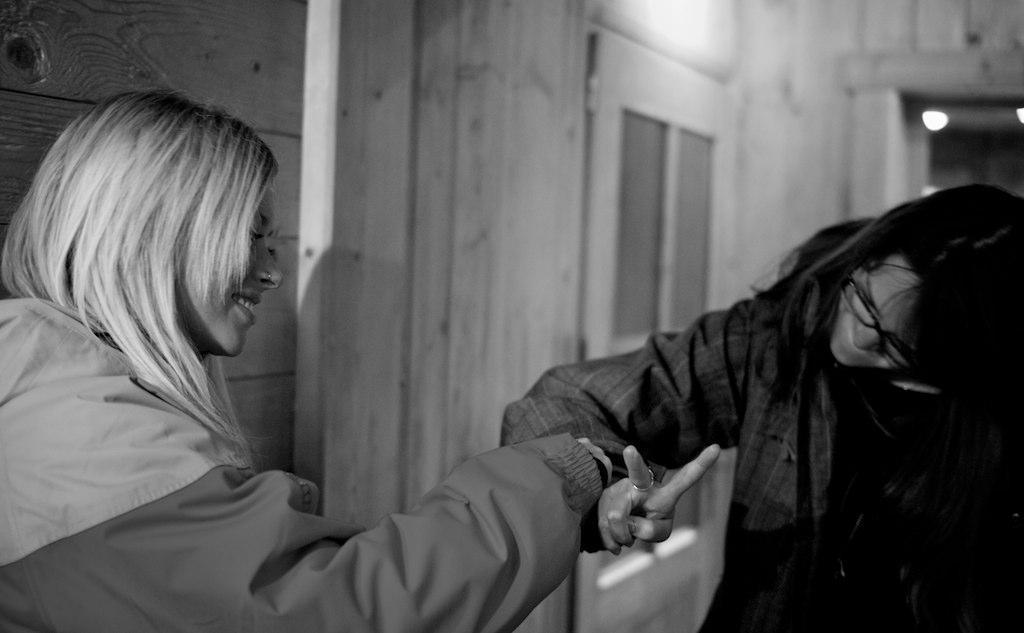In one or two sentences, can you explain what this image depicts? This is a black and white image and here we can see two people wearing coats and one of them is wearing glasses. In the background, we can see lights, a door and a wall. 